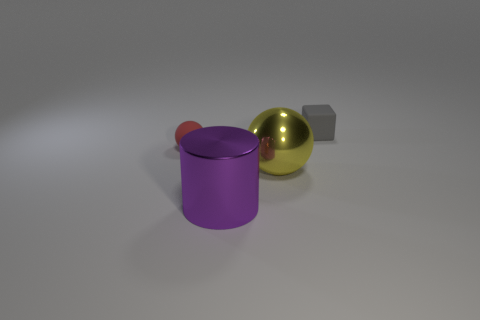There is a rubber object that is right of the small matte ball; is it the same shape as the yellow object?
Offer a terse response. No. There is a tiny rubber object on the left side of the large object that is in front of the big metal object behind the large cylinder; what color is it?
Your response must be concise. Red. Are there any small blue objects?
Your answer should be compact. No. What number of other things are the same size as the metal ball?
Provide a succinct answer. 1. What number of things are either tiny cyan shiny balls or gray matte objects?
Your answer should be very brief. 1. Is there anything else that is the same color as the cube?
Offer a very short reply. No. Does the big sphere have the same material as the large thing that is to the left of the large yellow shiny object?
Keep it short and to the point. Yes. The matte thing behind the small rubber thing on the left side of the large sphere is what shape?
Your answer should be very brief. Cube. The thing that is left of the small gray cube and behind the large sphere has what shape?
Your answer should be compact. Sphere. What number of objects are purple matte cylinders or tiny things that are right of the purple cylinder?
Give a very brief answer. 1. 